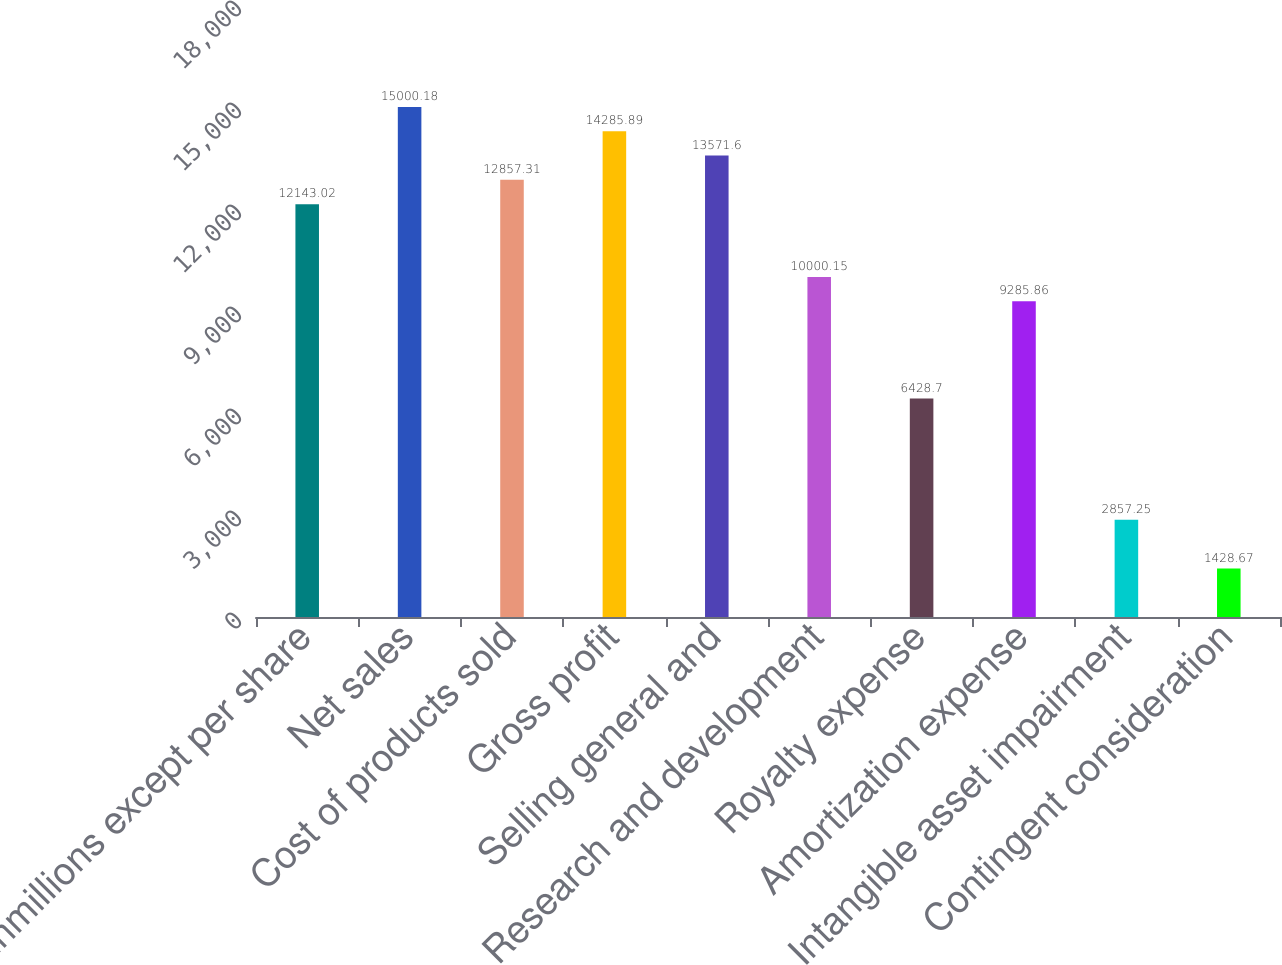Convert chart to OTSL. <chart><loc_0><loc_0><loc_500><loc_500><bar_chart><fcel>inmillions except per share<fcel>Net sales<fcel>Cost of products sold<fcel>Gross profit<fcel>Selling general and<fcel>Research and development<fcel>Royalty expense<fcel>Amortization expense<fcel>Intangible asset impairment<fcel>Contingent consideration<nl><fcel>12143<fcel>15000.2<fcel>12857.3<fcel>14285.9<fcel>13571.6<fcel>10000.1<fcel>6428.7<fcel>9285.86<fcel>2857.25<fcel>1428.67<nl></chart> 